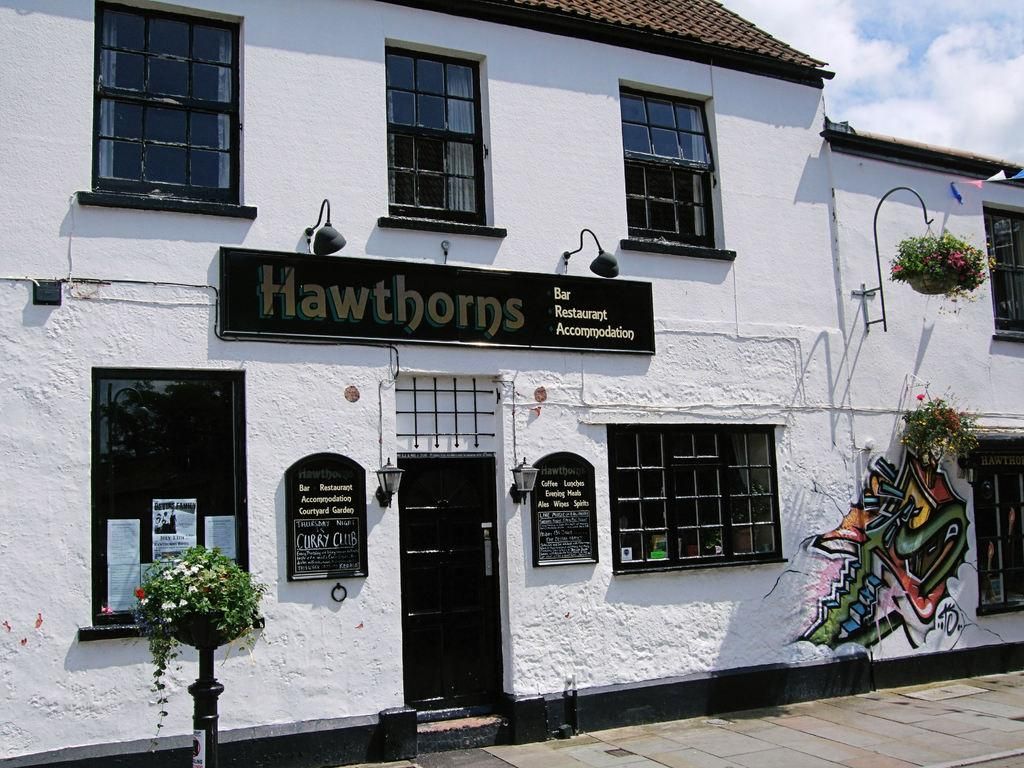What is the main structure visible in the image? There is a hoarding in the image. What type of vegetation is present in the image? There are plants in the image. What type of material is used for the windows in the image? There are glass windows in the image. What is the entrance to the structure in the image? There is a door in the image. What can be seen in the sky in the image? Clouds are visible in the sky in the image. What type of songs can be heard coming from the basket in the image? There is no basket present in the image, and therefore no songs can be heard. 